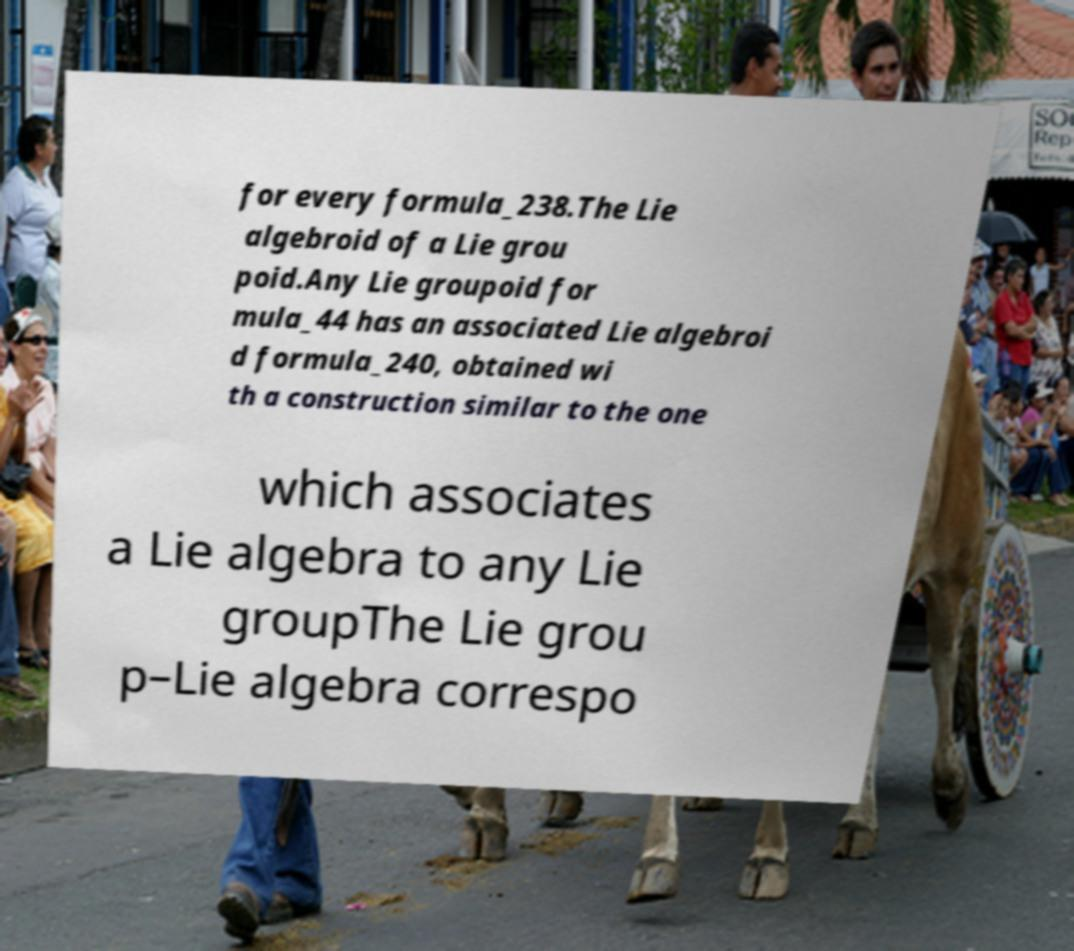Could you extract and type out the text from this image? for every formula_238.The Lie algebroid of a Lie grou poid.Any Lie groupoid for mula_44 has an associated Lie algebroi d formula_240, obtained wi th a construction similar to the one which associates a Lie algebra to any Lie groupThe Lie grou p–Lie algebra correspo 